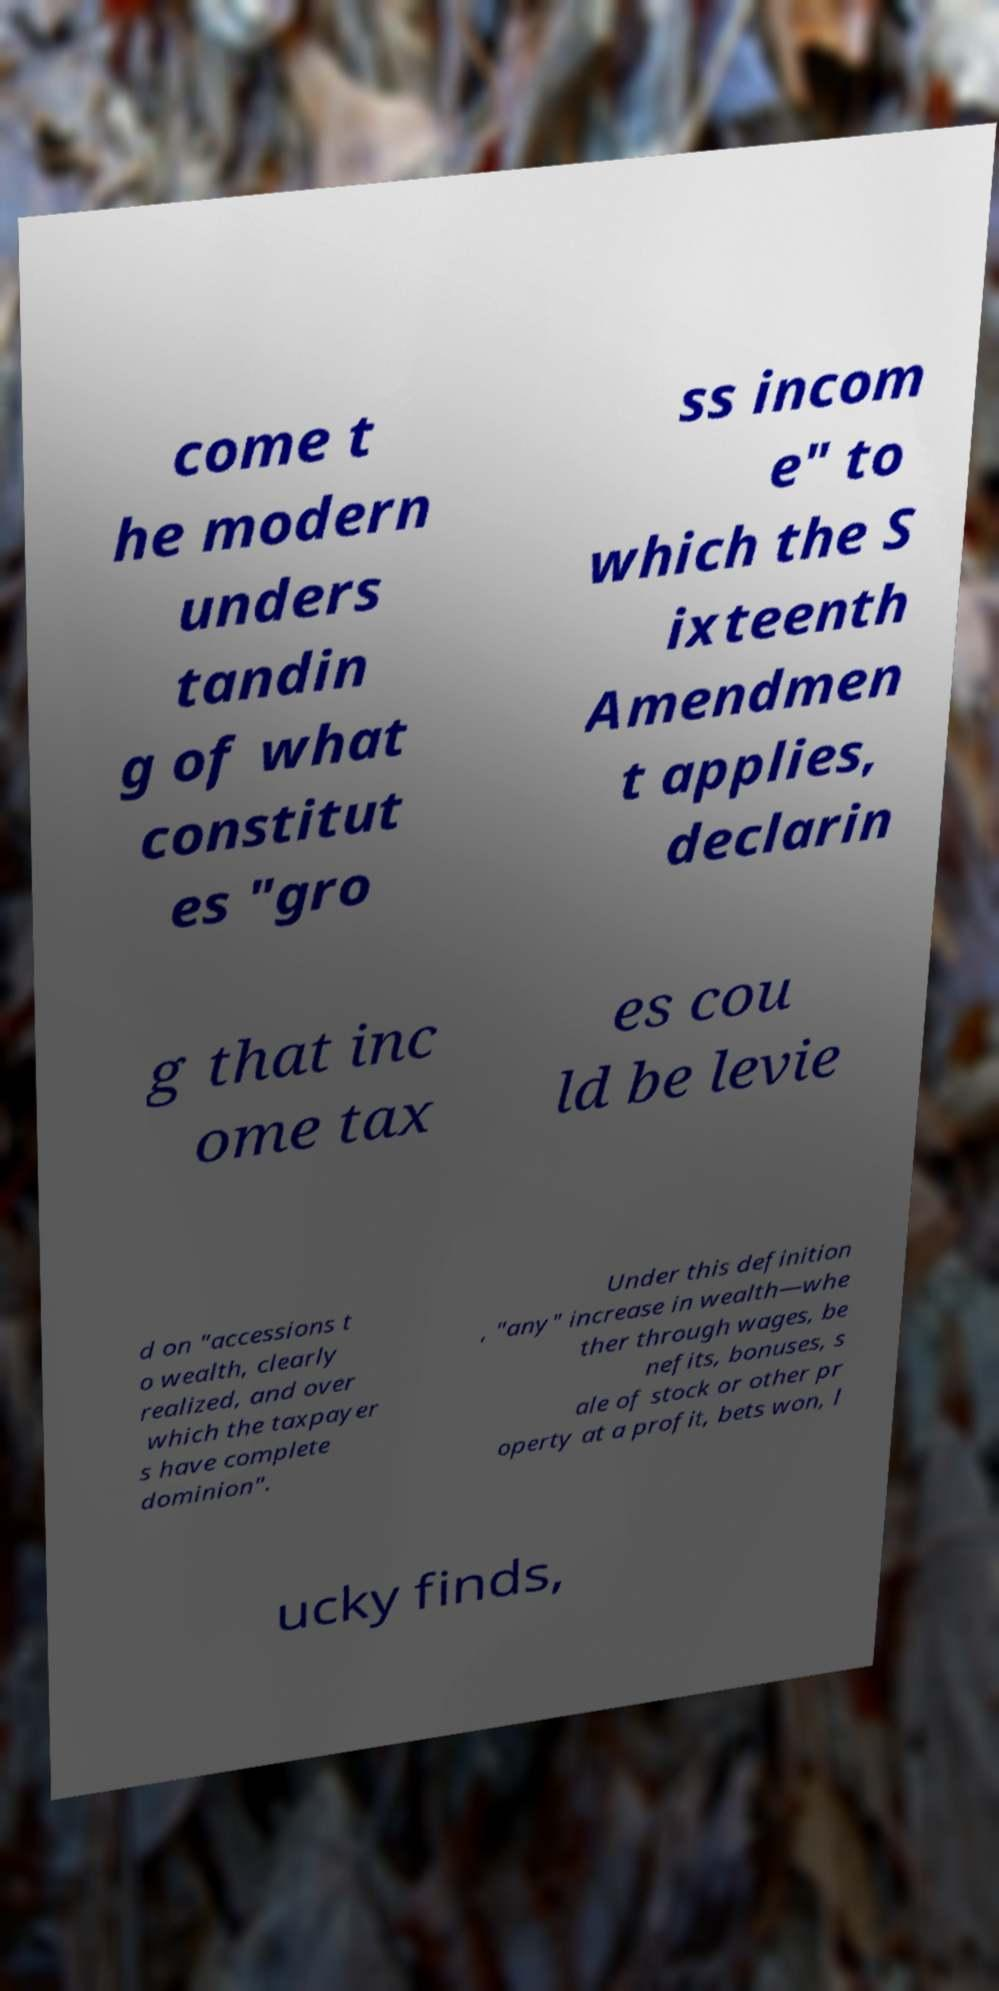Could you assist in decoding the text presented in this image and type it out clearly? come t he modern unders tandin g of what constitut es "gro ss incom e" to which the S ixteenth Amendmen t applies, declarin g that inc ome tax es cou ld be levie d on "accessions t o wealth, clearly realized, and over which the taxpayer s have complete dominion". Under this definition , "any" increase in wealth—whe ther through wages, be nefits, bonuses, s ale of stock or other pr operty at a profit, bets won, l ucky finds, 